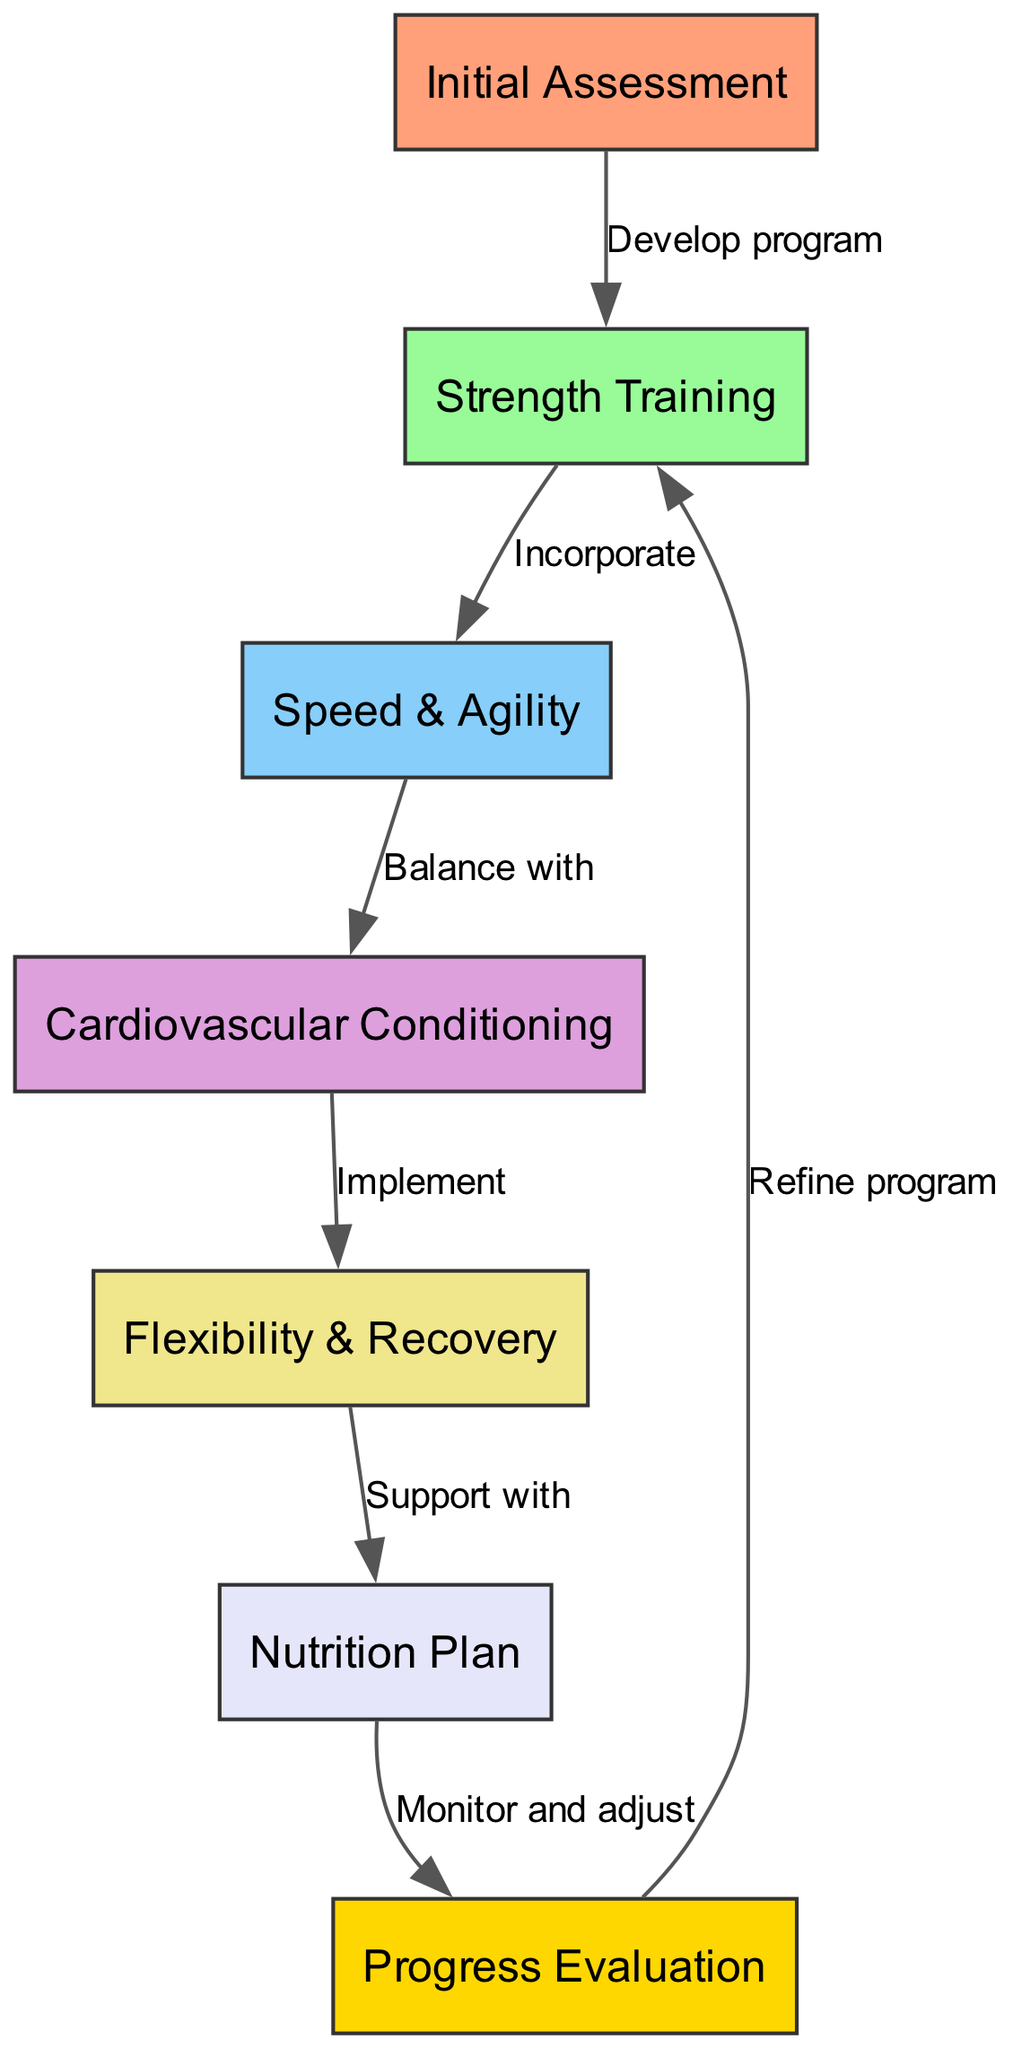What is the first step in the flow chart? The first step is labeled as "Initial Assessment", which is the starting point of the training program.
Answer: Initial Assessment How many nodes are present in the diagram? The diagram has a total of 7 nodes representing different aspects of the training program.
Answer: 7 What does the edge from "Flexibility & Recovery" to "Nutrition Plan" indicate? This edge labeled "Support with" indicates that flexibility and recovery practices are aligned with the nutritional aspects of the program to enhance overall training effectiveness.
Answer: Support with Which node follows "Speed & Agility"? The node that follows "Speed & Agility" is "Cardiovascular Conditioning", indicating the flow from improving speed and agility into cardiovascular fitness.
Answer: Cardiovascular Conditioning What process occurs after "Progress Evaluation"? After "Progress Evaluation", the program is refined as indicated by the edge that points back to "Strength Training" for adjustments based on the evaluation findings.
Answer: Refine program How is "Strength Training" connected to "Speed & Agility"? "Strength Training" is connected to "Speed & Agility" with the edge labeled "Incorporate", which shows that strength training is integrated into the speed and agility training regimen.
Answer: Incorporate What aspect does "Nutrition Plan" support in the diagram? The "Nutrition Plan" supports "Flexibility & Recovery", meaning that nutritional strategies are designed to aid in recovery and flexibility in the training program.
Answer: Support with 